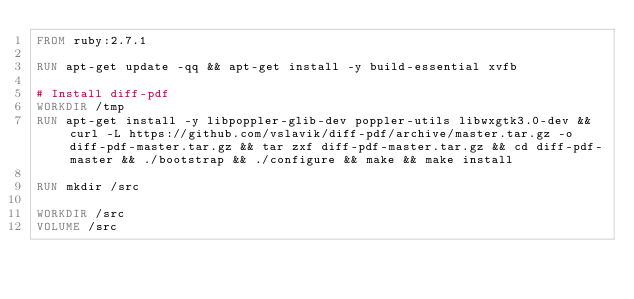Convert code to text. <code><loc_0><loc_0><loc_500><loc_500><_Dockerfile_>FROM ruby:2.7.1

RUN apt-get update -qq && apt-get install -y build-essential xvfb

# Install diff-pdf
WORKDIR /tmp
RUN apt-get install -y libpoppler-glib-dev poppler-utils libwxgtk3.0-dev && curl -L https://github.com/vslavik/diff-pdf/archive/master.tar.gz -o diff-pdf-master.tar.gz && tar zxf diff-pdf-master.tar.gz && cd diff-pdf-master && ./bootstrap && ./configure && make && make install

RUN mkdir /src

WORKDIR /src
VOLUME /src
</code> 